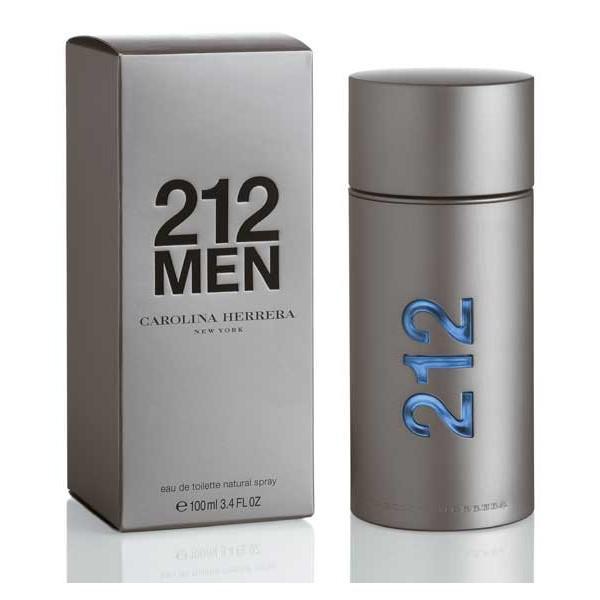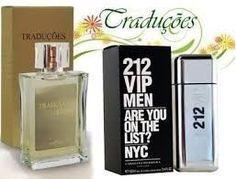The first image is the image on the left, the second image is the image on the right. Considering the images on both sides, is "One image shows a silver cylinder shape next to a silver upright box." valid? Answer yes or no. Yes. The first image is the image on the left, the second image is the image on the right. For the images shown, is this caption "There are more containers in the image on the right." true? Answer yes or no. Yes. 